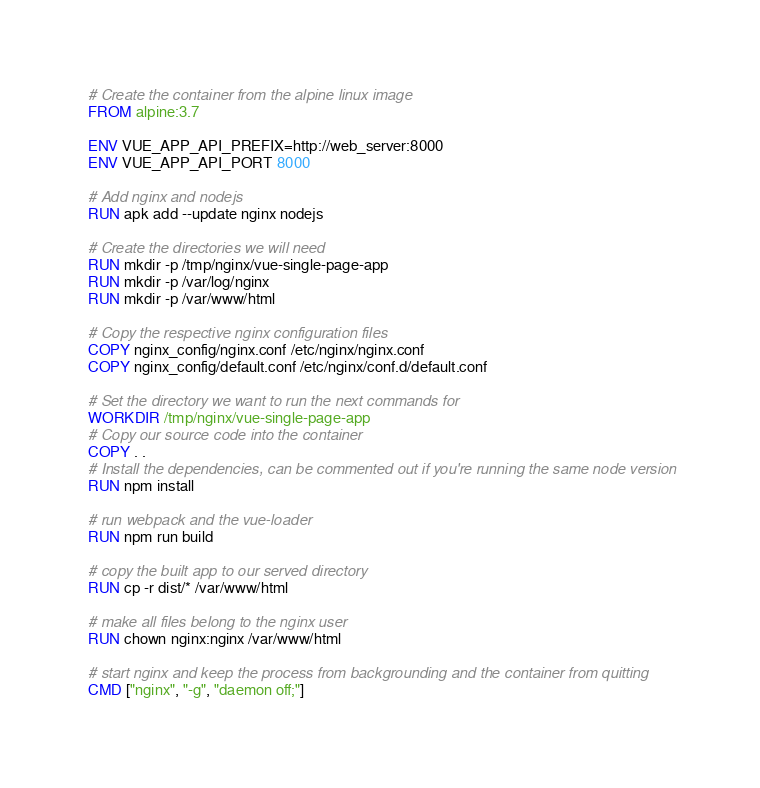<code> <loc_0><loc_0><loc_500><loc_500><_Dockerfile_># Create the container from the alpine linux image
FROM alpine:3.7

ENV VUE_APP_API_PREFIX=http://web_server:8000
ENV VUE_APP_API_PORT 8000

# Add nginx and nodejs
RUN apk add --update nginx nodejs

# Create the directories we will need
RUN mkdir -p /tmp/nginx/vue-single-page-app
RUN mkdir -p /var/log/nginx
RUN mkdir -p /var/www/html

# Copy the respective nginx configuration files
COPY nginx_config/nginx.conf /etc/nginx/nginx.conf
COPY nginx_config/default.conf /etc/nginx/conf.d/default.conf

# Set the directory we want to run the next commands for
WORKDIR /tmp/nginx/vue-single-page-app
# Copy our source code into the container
COPY . .
# Install the dependencies, can be commented out if you're running the same node version
RUN npm install

# run webpack and the vue-loader
RUN npm run build

# copy the built app to our served directory
RUN cp -r dist/* /var/www/html

# make all files belong to the nginx user
RUN chown nginx:nginx /var/www/html

# start nginx and keep the process from backgrounding and the container from quitting
CMD ["nginx", "-g", "daemon off;"]</code> 